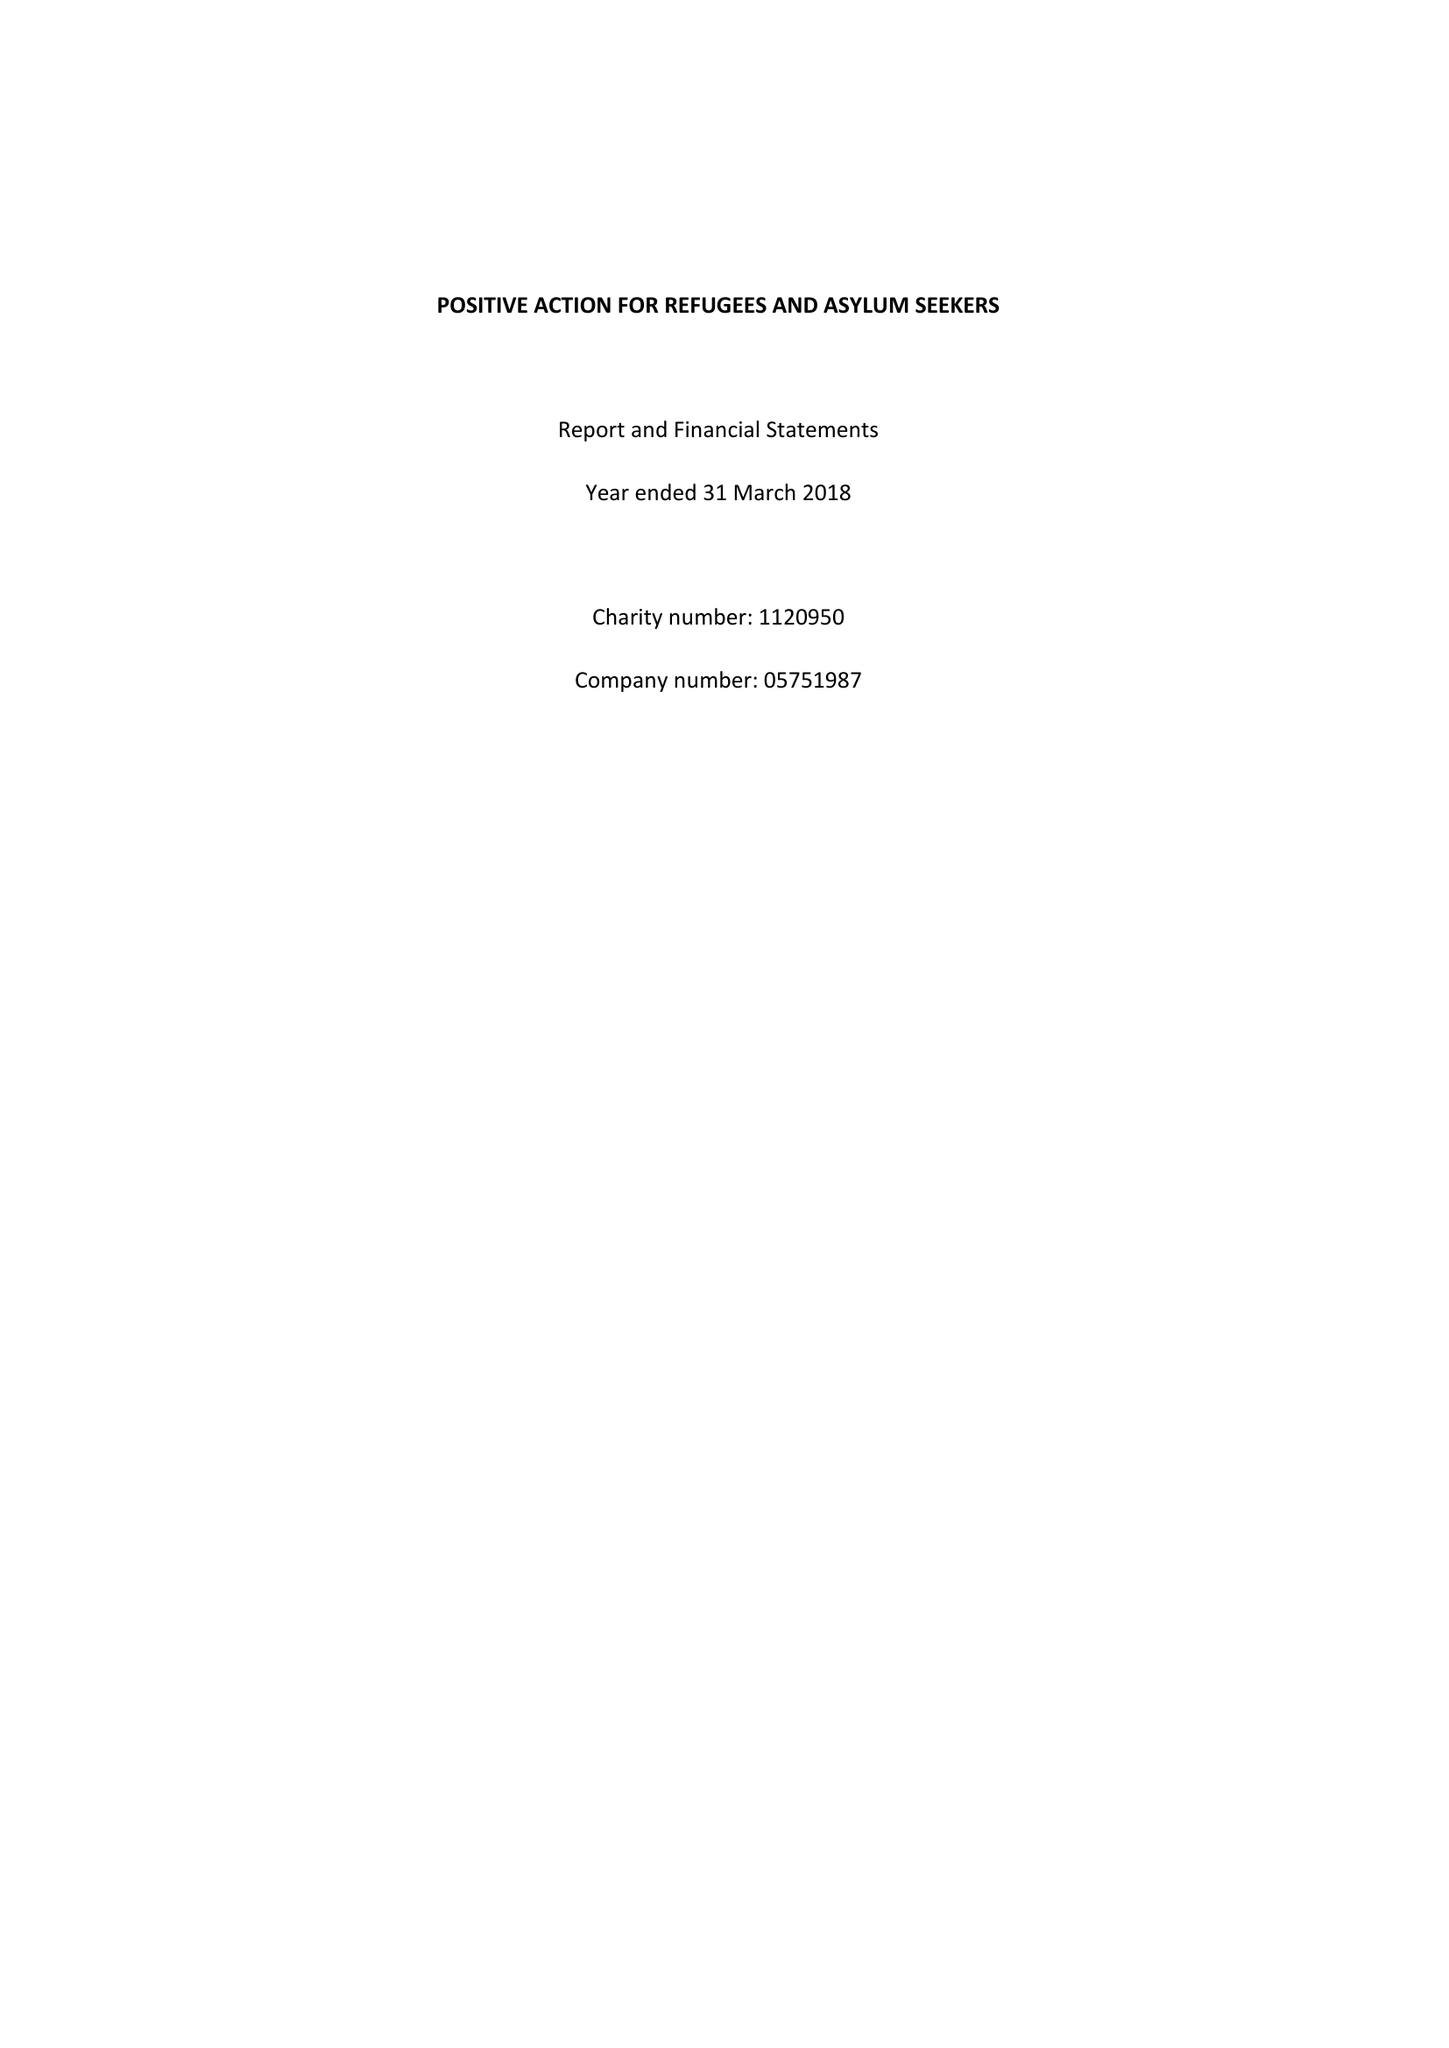What is the value for the spending_annually_in_british_pounds?
Answer the question using a single word or phrase. 217666.00 